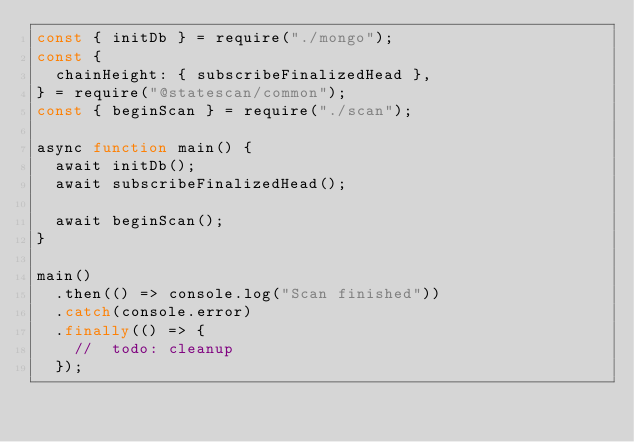<code> <loc_0><loc_0><loc_500><loc_500><_JavaScript_>const { initDb } = require("./mongo");
const {
  chainHeight: { subscribeFinalizedHead },
} = require("@statescan/common");
const { beginScan } = require("./scan");

async function main() {
  await initDb();
  await subscribeFinalizedHead();

  await beginScan();
}

main()
  .then(() => console.log("Scan finished"))
  .catch(console.error)
  .finally(() => {
    //  todo: cleanup
  });
</code> 